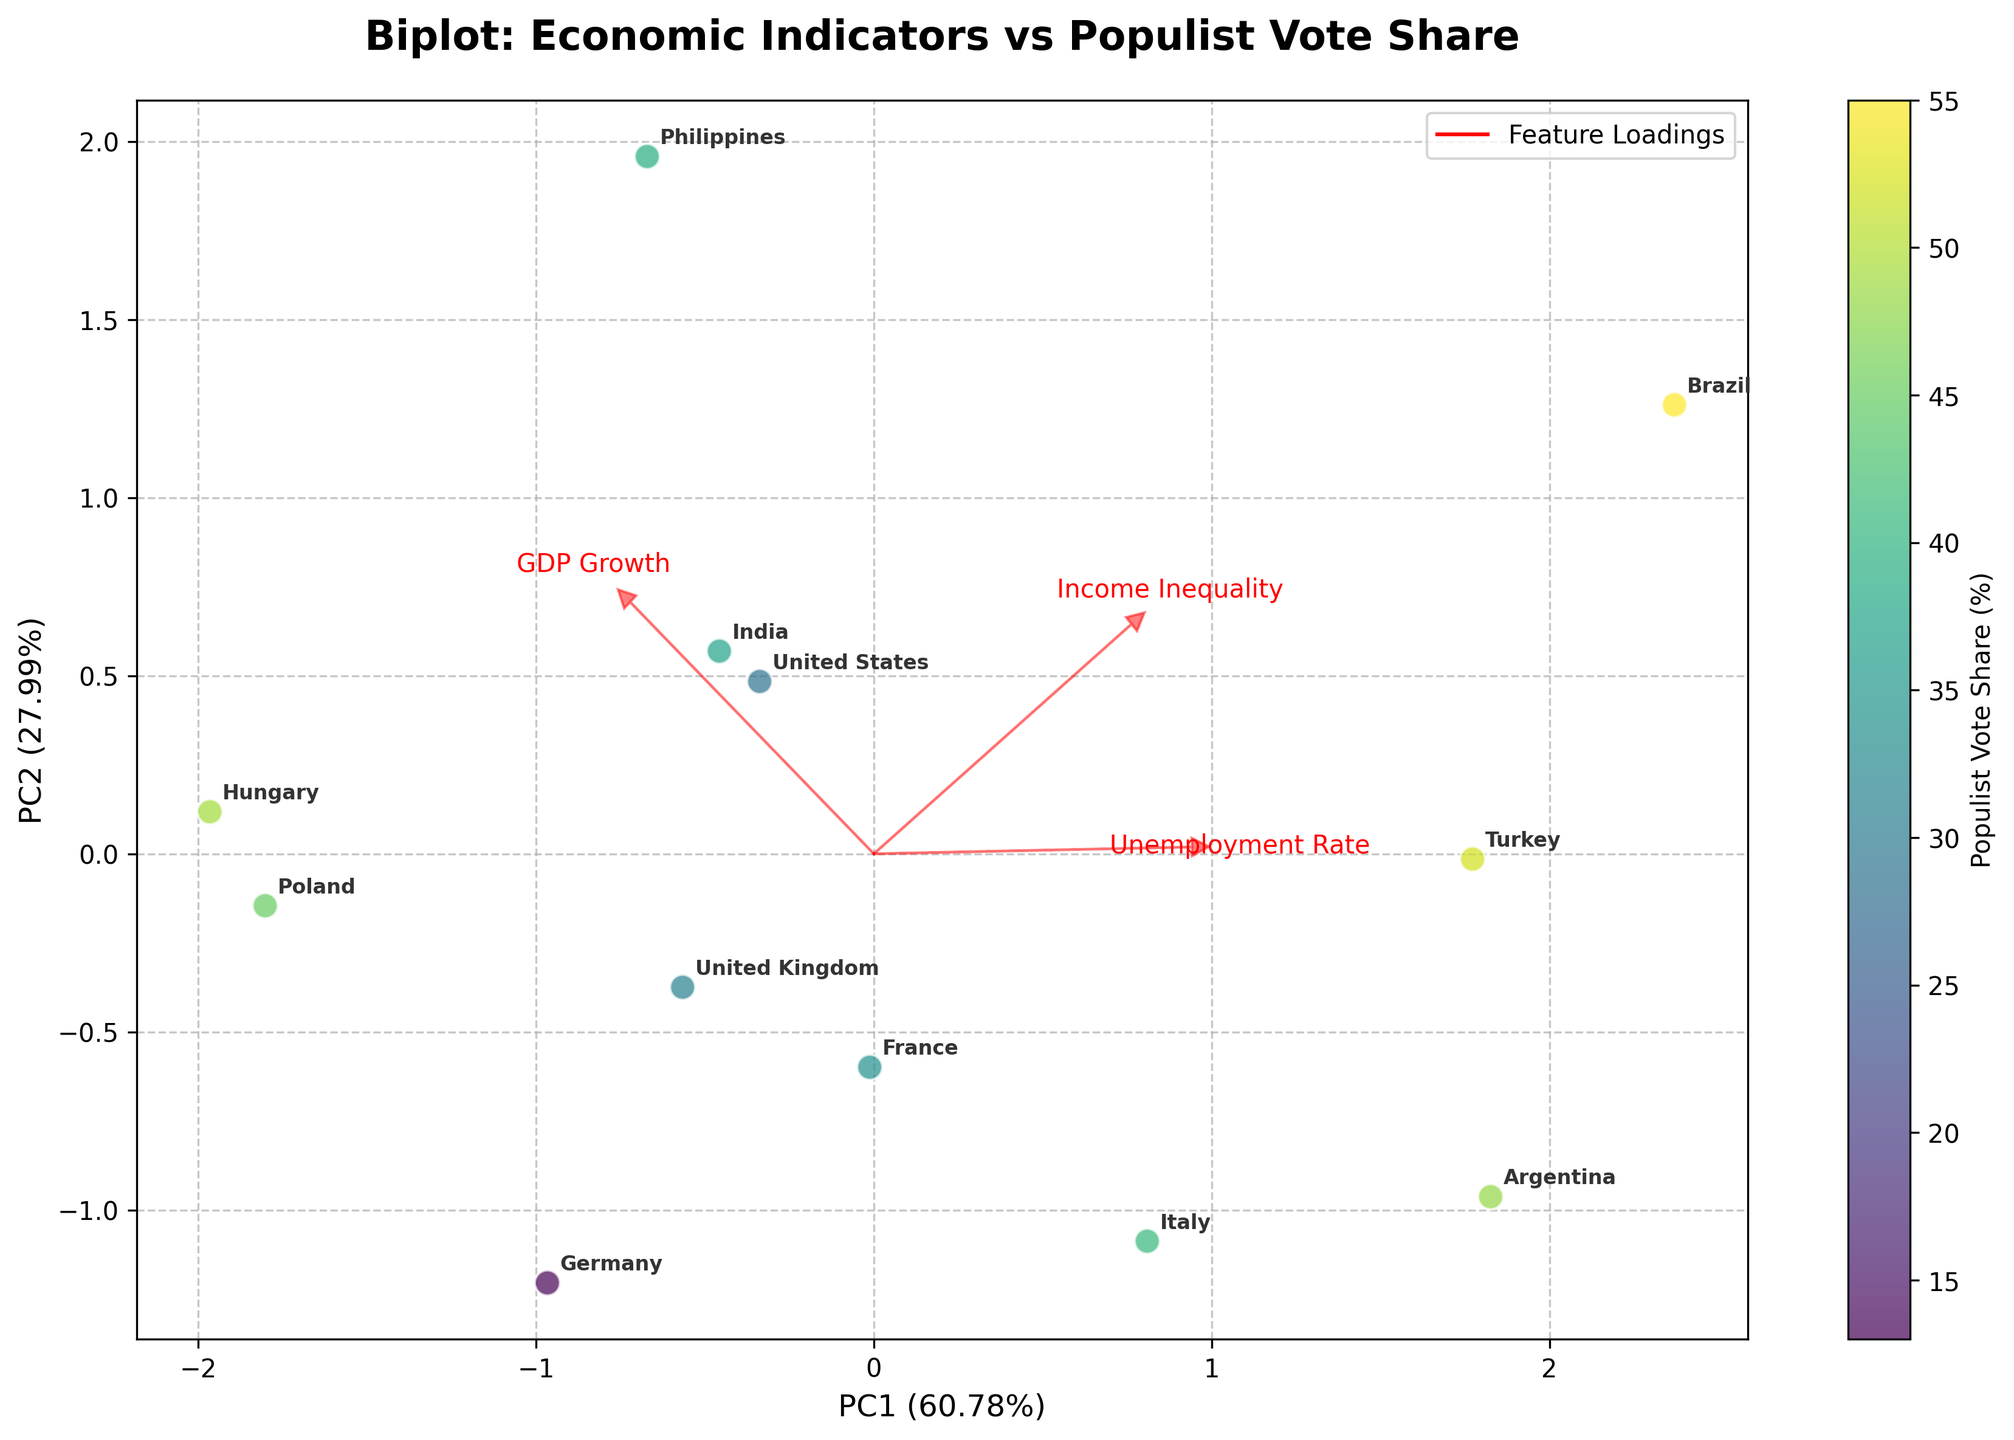What's the title of the figure? The title of a figure is usually found at the top. For this biplot, it says "Biplot: Economic Indicators vs Populist Vote Share".
Answer: Biplot: Economic Indicators vs Populist Vote Share How many economic indicators are shown with arrows? Arrows are used to represent economic indicators in a biplot. In this figure, four arrows are visible, each corresponding to an economic indicator: GDP Growth, Unemployment Rate, Income Inequality, and Populist Vote Share.
Answer: Four Which region has the highest Populist Vote Share? The Populist Vote Share can be indicated by the color intensity in the scatter plot. The region with the darkest color will have the highest value. Based on this, Brazil appears to have the highest populist vote share.
Answer: Brazil Which economic indicator is most closely aligned with the first principal component (PC1)? The first principal component (PC1) is represented by the horizontal axis. The economic indicator whose arrow is most closely aligned with the horizontal axis is aligned with PC1. GDP Growth seems to be most closely aligned with PC1.
Answer: GDP Growth What does the position of the United States suggest about its economic indicators? The position of the United States in the plane indicates its relationship to the principal components and economic indicators. It is positioned towards higher GDP Growth and relatively moderate values for Unemployment Rate and Income Inequality.
Answer: Higher GDP Growth, moderate Unemployment Rate and Income Inequality Compare the positions of Germany and Italy. Which one has higher GDP Growth? To compare GDP Growth, look at the direction of the GDP Growth arrow. Germany is positioned closer to the positive direction of GDP Growth compared to Italy, indicating higher GDP Growth for Germany.
Answer: Germany Which economic indicator is most closely aligned with the second principal component (PC2)? The second principal component (PC2) is represented by the vertical axis. The economic indicator whose arrow is most closely aligned with the vertical axis is aligned with PC2. Income Inequality seems to be most closely aligned with PC2.
Answer: Income Inequality What economic indicator does the position of Argentina suggest a high value in? Argentina's position on the plot is close to the Unemployment Rate arrow. This suggests that Argentina has a relatively high Unemployment Rate.
Answer: Unemployment Rate Is Income Inequality positively or negatively associated with the first principal component (PC1)? Observe the direction of the Income Inequality arrow relative to the horizontal axis (PC1). The arrow points slightly negative relative to the horizontal axis, indicating a slight negative association.
Answer: Negatively How does the Populist Vote Share of the United Kingdom compare to that of Hungary? The Populist Vote Share is represented by the color of the scatter points. The United Kingdom has a lighter color compared to Hungary, indicating a lower Populist Vote Share for the United Kingdom.
Answer: Lower 